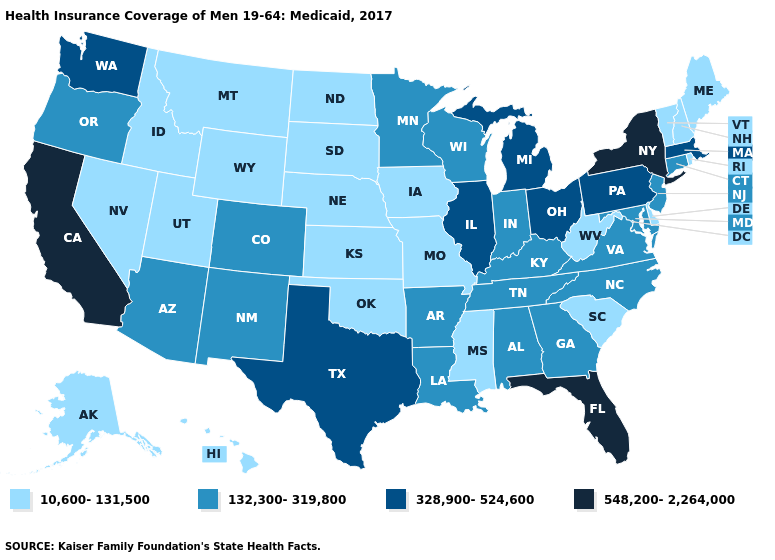Does the first symbol in the legend represent the smallest category?
Short answer required. Yes. What is the value of Michigan?
Write a very short answer. 328,900-524,600. Name the states that have a value in the range 328,900-524,600?
Write a very short answer. Illinois, Massachusetts, Michigan, Ohio, Pennsylvania, Texas, Washington. Is the legend a continuous bar?
Keep it brief. No. Which states hav the highest value in the West?
Quick response, please. California. Name the states that have a value in the range 132,300-319,800?
Short answer required. Alabama, Arizona, Arkansas, Colorado, Connecticut, Georgia, Indiana, Kentucky, Louisiana, Maryland, Minnesota, New Jersey, New Mexico, North Carolina, Oregon, Tennessee, Virginia, Wisconsin. What is the value of North Dakota?
Write a very short answer. 10,600-131,500. What is the lowest value in the USA?
Give a very brief answer. 10,600-131,500. How many symbols are there in the legend?
Quick response, please. 4. Among the states that border South Carolina , which have the lowest value?
Answer briefly. Georgia, North Carolina. What is the lowest value in states that border Massachusetts?
Short answer required. 10,600-131,500. Does South Dakota have the lowest value in the USA?
Give a very brief answer. Yes. Does New Jersey have a lower value than New Mexico?
Write a very short answer. No. Name the states that have a value in the range 10,600-131,500?
Quick response, please. Alaska, Delaware, Hawaii, Idaho, Iowa, Kansas, Maine, Mississippi, Missouri, Montana, Nebraska, Nevada, New Hampshire, North Dakota, Oklahoma, Rhode Island, South Carolina, South Dakota, Utah, Vermont, West Virginia, Wyoming. 